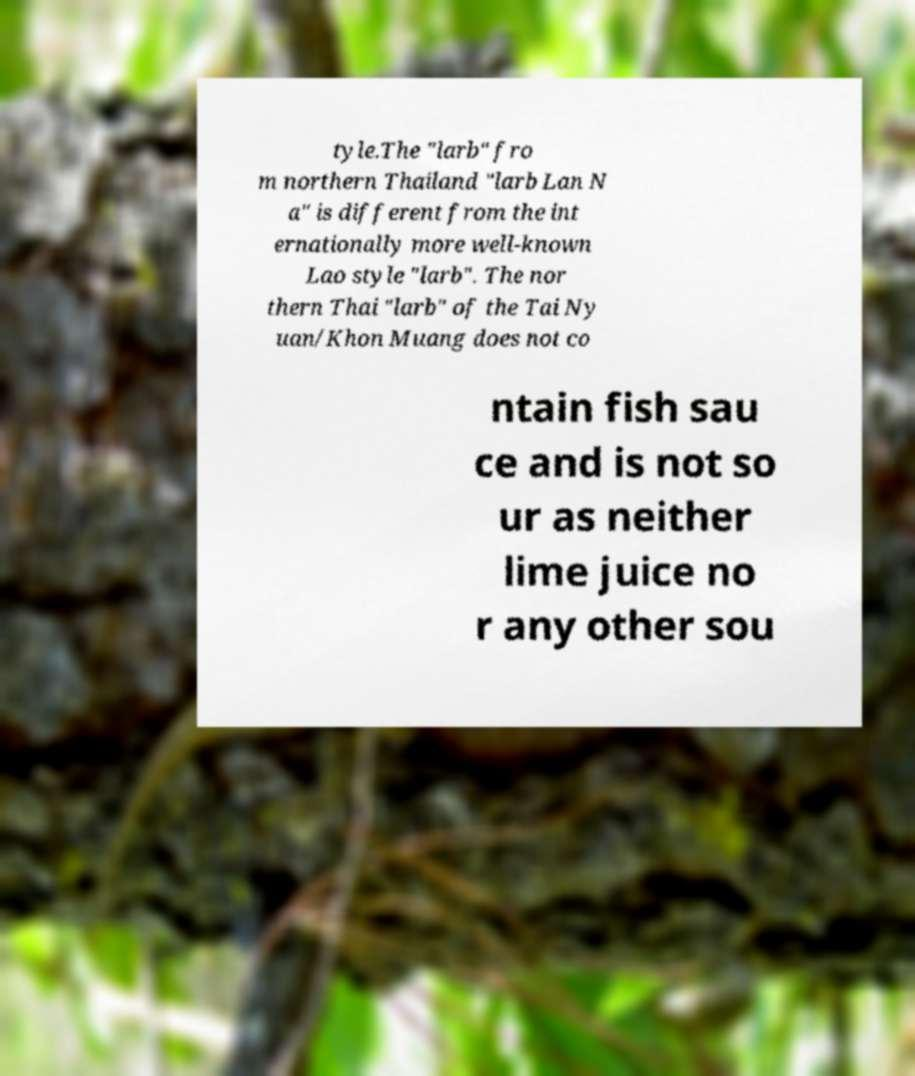For documentation purposes, I need the text within this image transcribed. Could you provide that? tyle.The "larb" fro m northern Thailand "larb Lan N a" is different from the int ernationally more well-known Lao style "larb". The nor thern Thai "larb" of the Tai Ny uan/Khon Muang does not co ntain fish sau ce and is not so ur as neither lime juice no r any other sou 